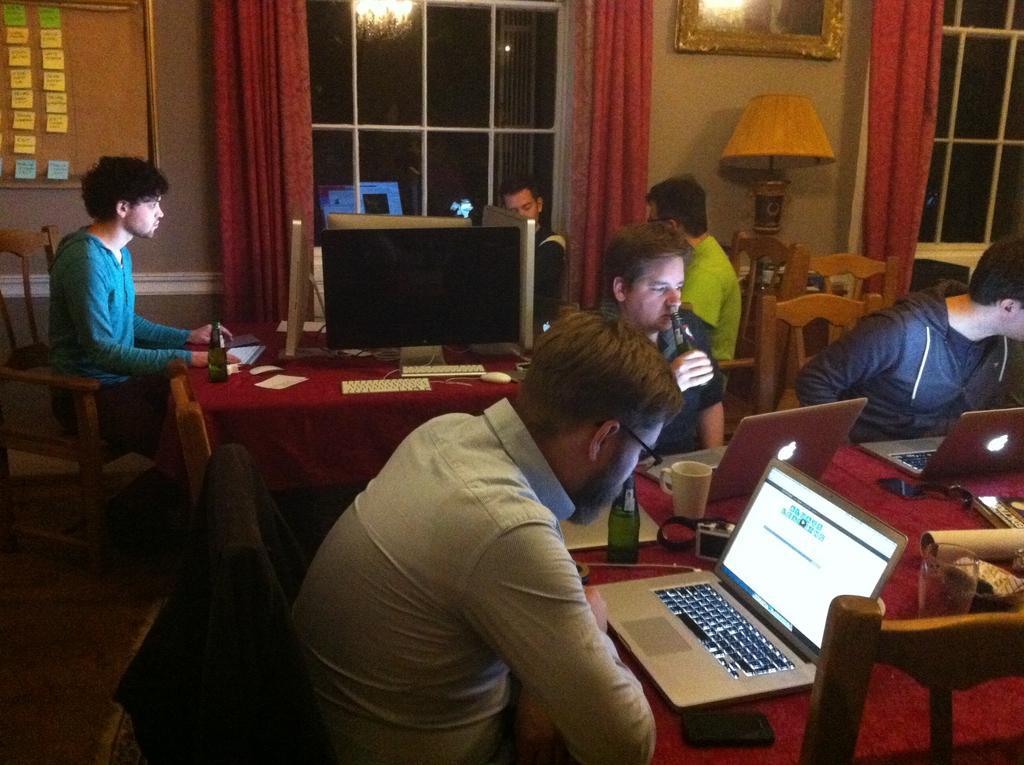Can you describe this image briefly? In this image I can see a group of people are sitting on a chair in front of a table. On the table I can see there is a laptop and other objects on it. 